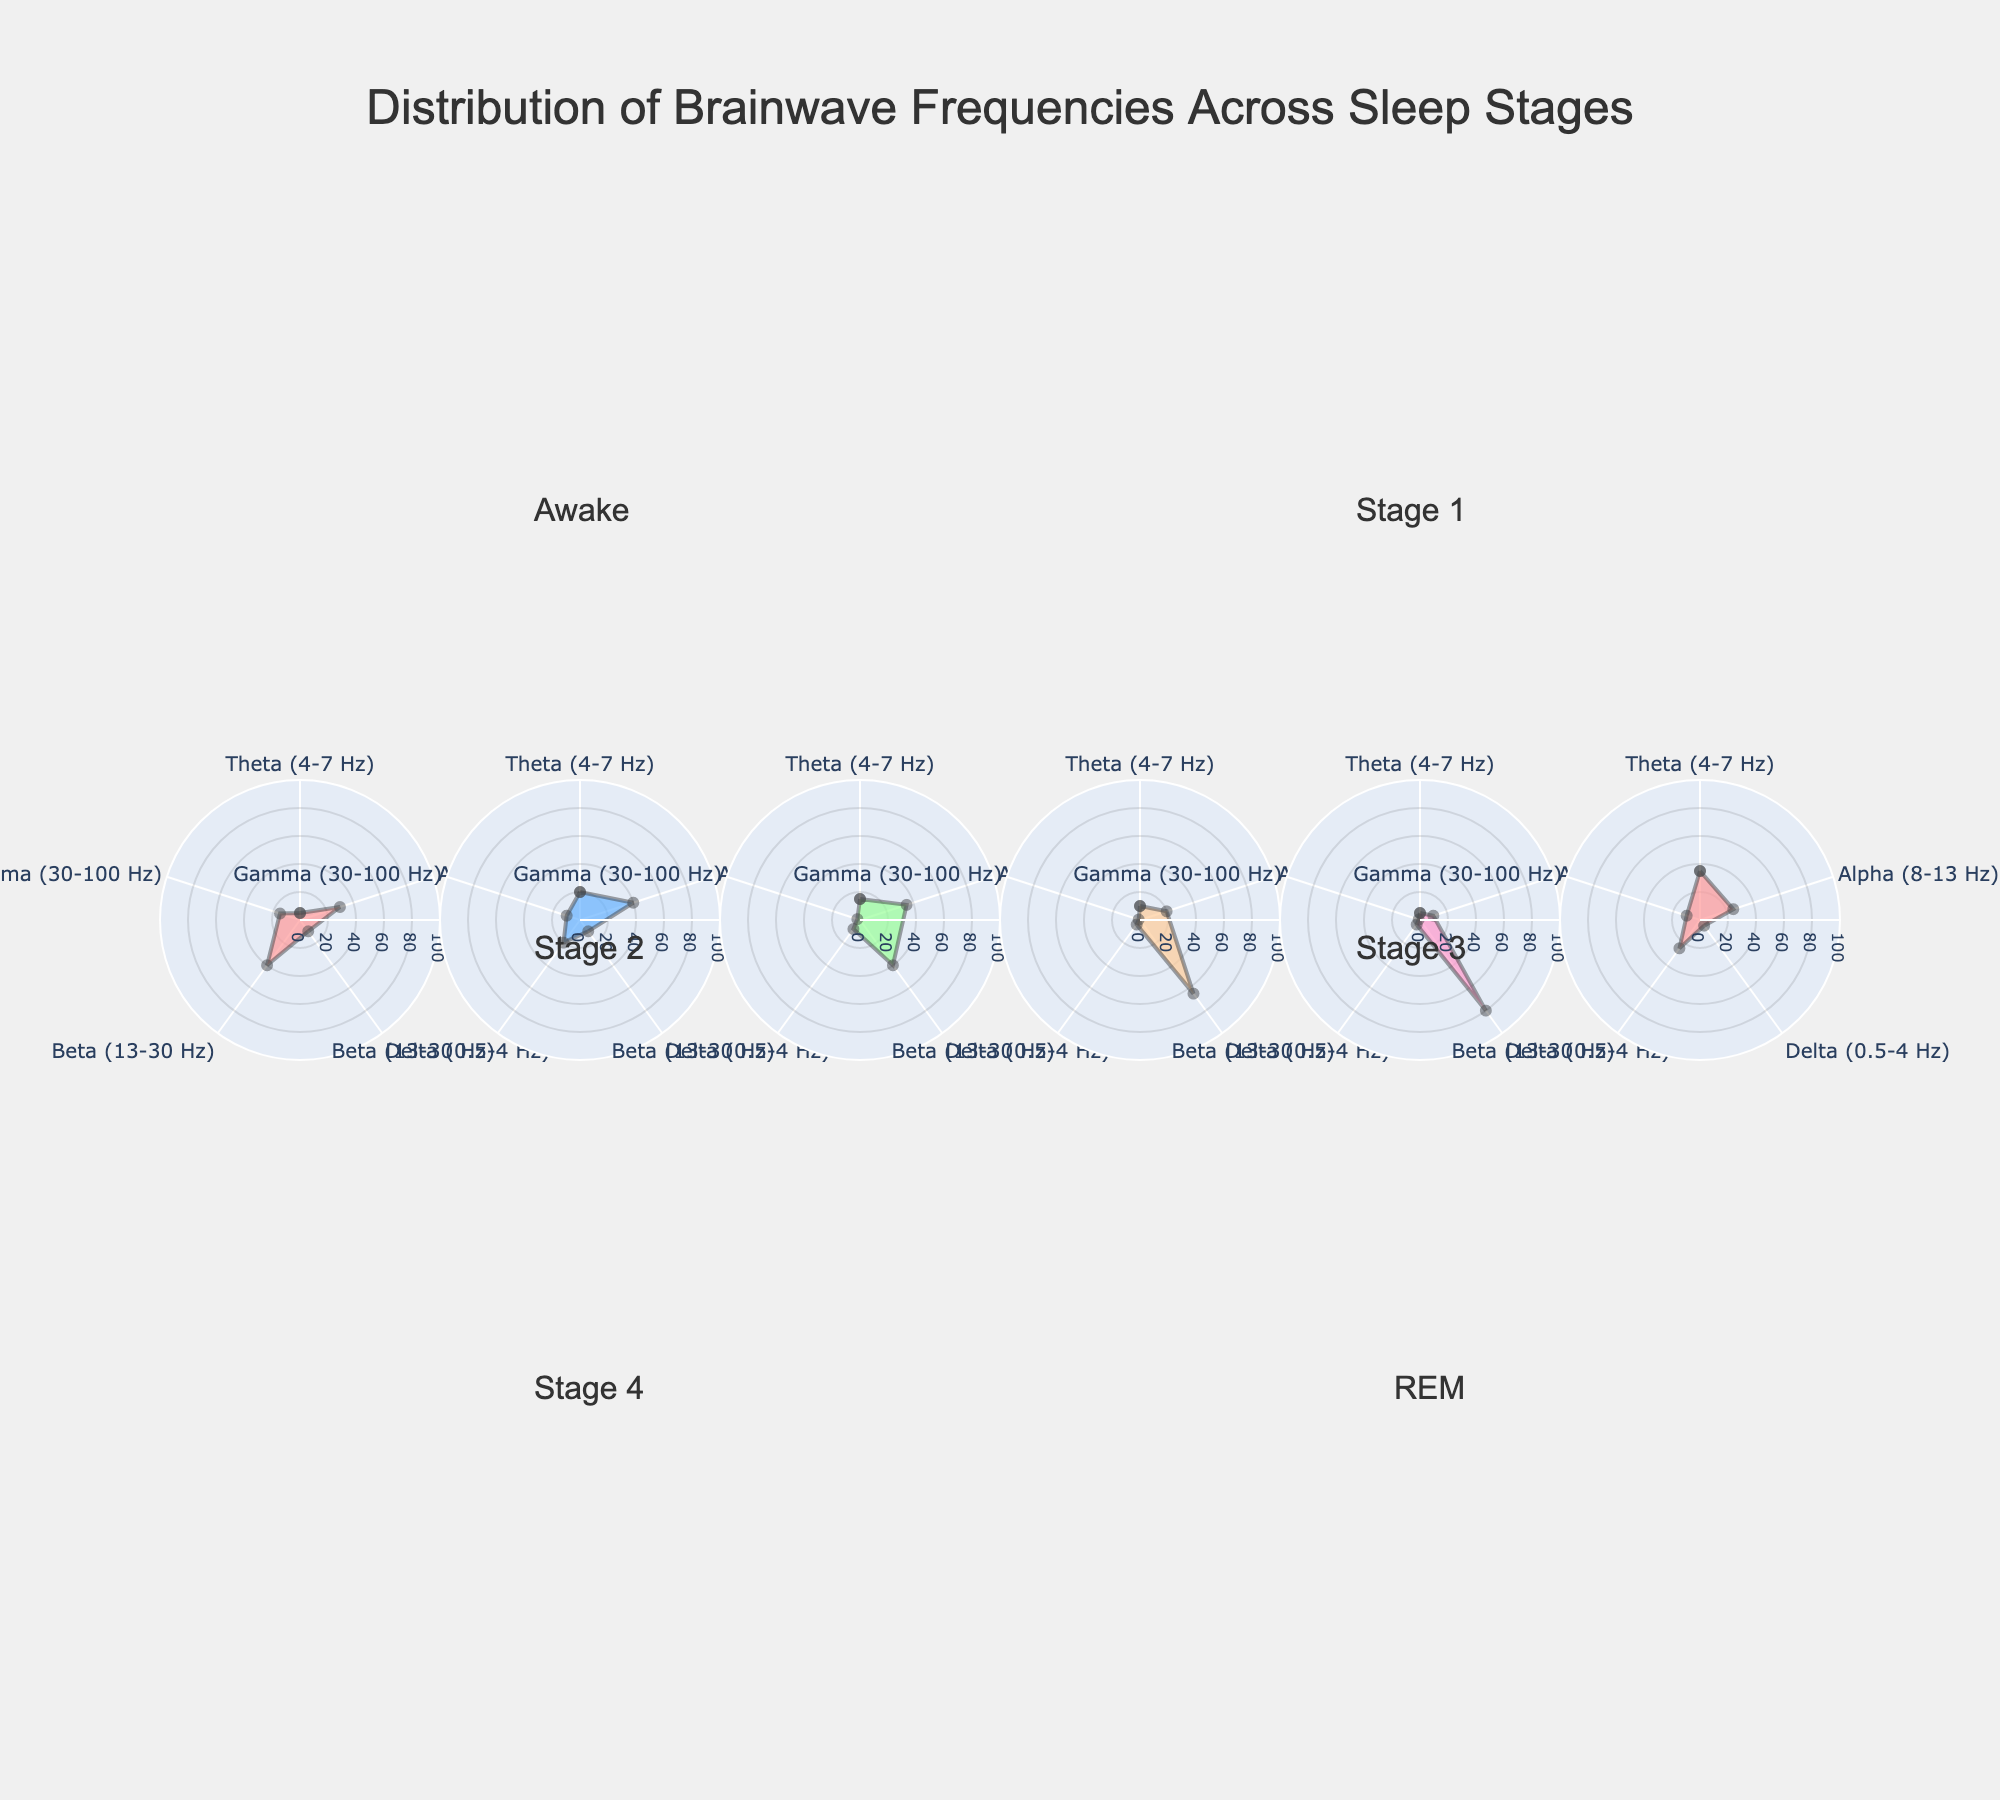What is the title of the figure? The title of the figure is usually displayed prominently at the top. In this case, it reads "Distribution of Brainwave Frequencies Across Sleep Stages".
Answer: Distribution of Brainwave Frequencies Across Sleep Stages Which brainwave frequency has the highest value during the awake stage? To find this, look at the radial axis values of the 'Awake' stage subplot, and identify which brainwave frequency has the highest corresponding value. The highest value is for Beta (13-30 Hz) at 40.
Answer: Beta (13-30 Hz) In which stage is Delta (0.5-4 Hz) the most dominant? Identify the stage with the highest value for Delta (0.5-4 Hz) by looking at the subplots. The stage with the highest Delta value is Stage 4, with a value of 80.
Answer: Stage 4 Compare the Alpha (8-13 Hz) frequencies between Stage 3 and REM. Which stage has a higher value and by how much? Look at the values for Alpha (8-13 Hz) in both Stage 3 and REM subplots. REM has an Alpha value of 25, and Stage 3 has an Alpha value of 20. The difference is 25 - 20 = 5.
Answer: REM by 5 What is the sum of Gamma (30-100 Hz) frequencies across all stages? Add the Gamma values from each stage: Awake (15) + Stage 1 (10) + Stage 2 (2) + Stage 3 (1) + Stage 4 (1) + REM (10). The sum is 15 + 10 + 2 + 1 + 1 + 10 = 39.
Answer: 39 Which sleep stage has the smallest contribution from Beta (13-30 Hz) brainwaves? Look at the Beta values in each stage and identify the smallest one. The smallest value is 4, found in both Stage 3 and Stage 4.
Answer: Stage 3 and Stage 4 How do the Theta (4-7 Hz) frequencies in Stage 2 compare to those in REM? Compare the Theta values in Stage 2 and REM found in their respective subplots. Theta for Stage 2 is 15, and for REM, it is 35. REM has a higher Theta frequency by 35 - 15 = 20.
Answer: REM is higher by 20 What is the average of Delta (0.5-4 Hz) frequencies during non-REM stages (Stage 1-4)? Calculate the average Delta frequency for non-REM stages by summing the Delta values for Stage 1 to Stage 4 and dividing by the number of stages. (10 + 40 + 65 + 80) / 4 = 195 / 4 = 48.75.
Answer: 48.75 Which brainwave frequency shows the most variation across different sleep stages? Assess the variation in each brainwave frequency (Theta, Alpha, Delta, Beta, Gamma) using their range (i.e., maximum value - minimum value). Delta shows the most variation: max (80 in Stage 4) - min (5 in REM) = 75.
Answer: Delta How does Beta (13-30 Hz) frequency change from Awake to Stage 4? Identify the Beta values in Awake (40) and Stage 4 (4), then find the difference: 40 - 4 = 36. There's a significant reduction of 36.
Answer: Reduces by 36 